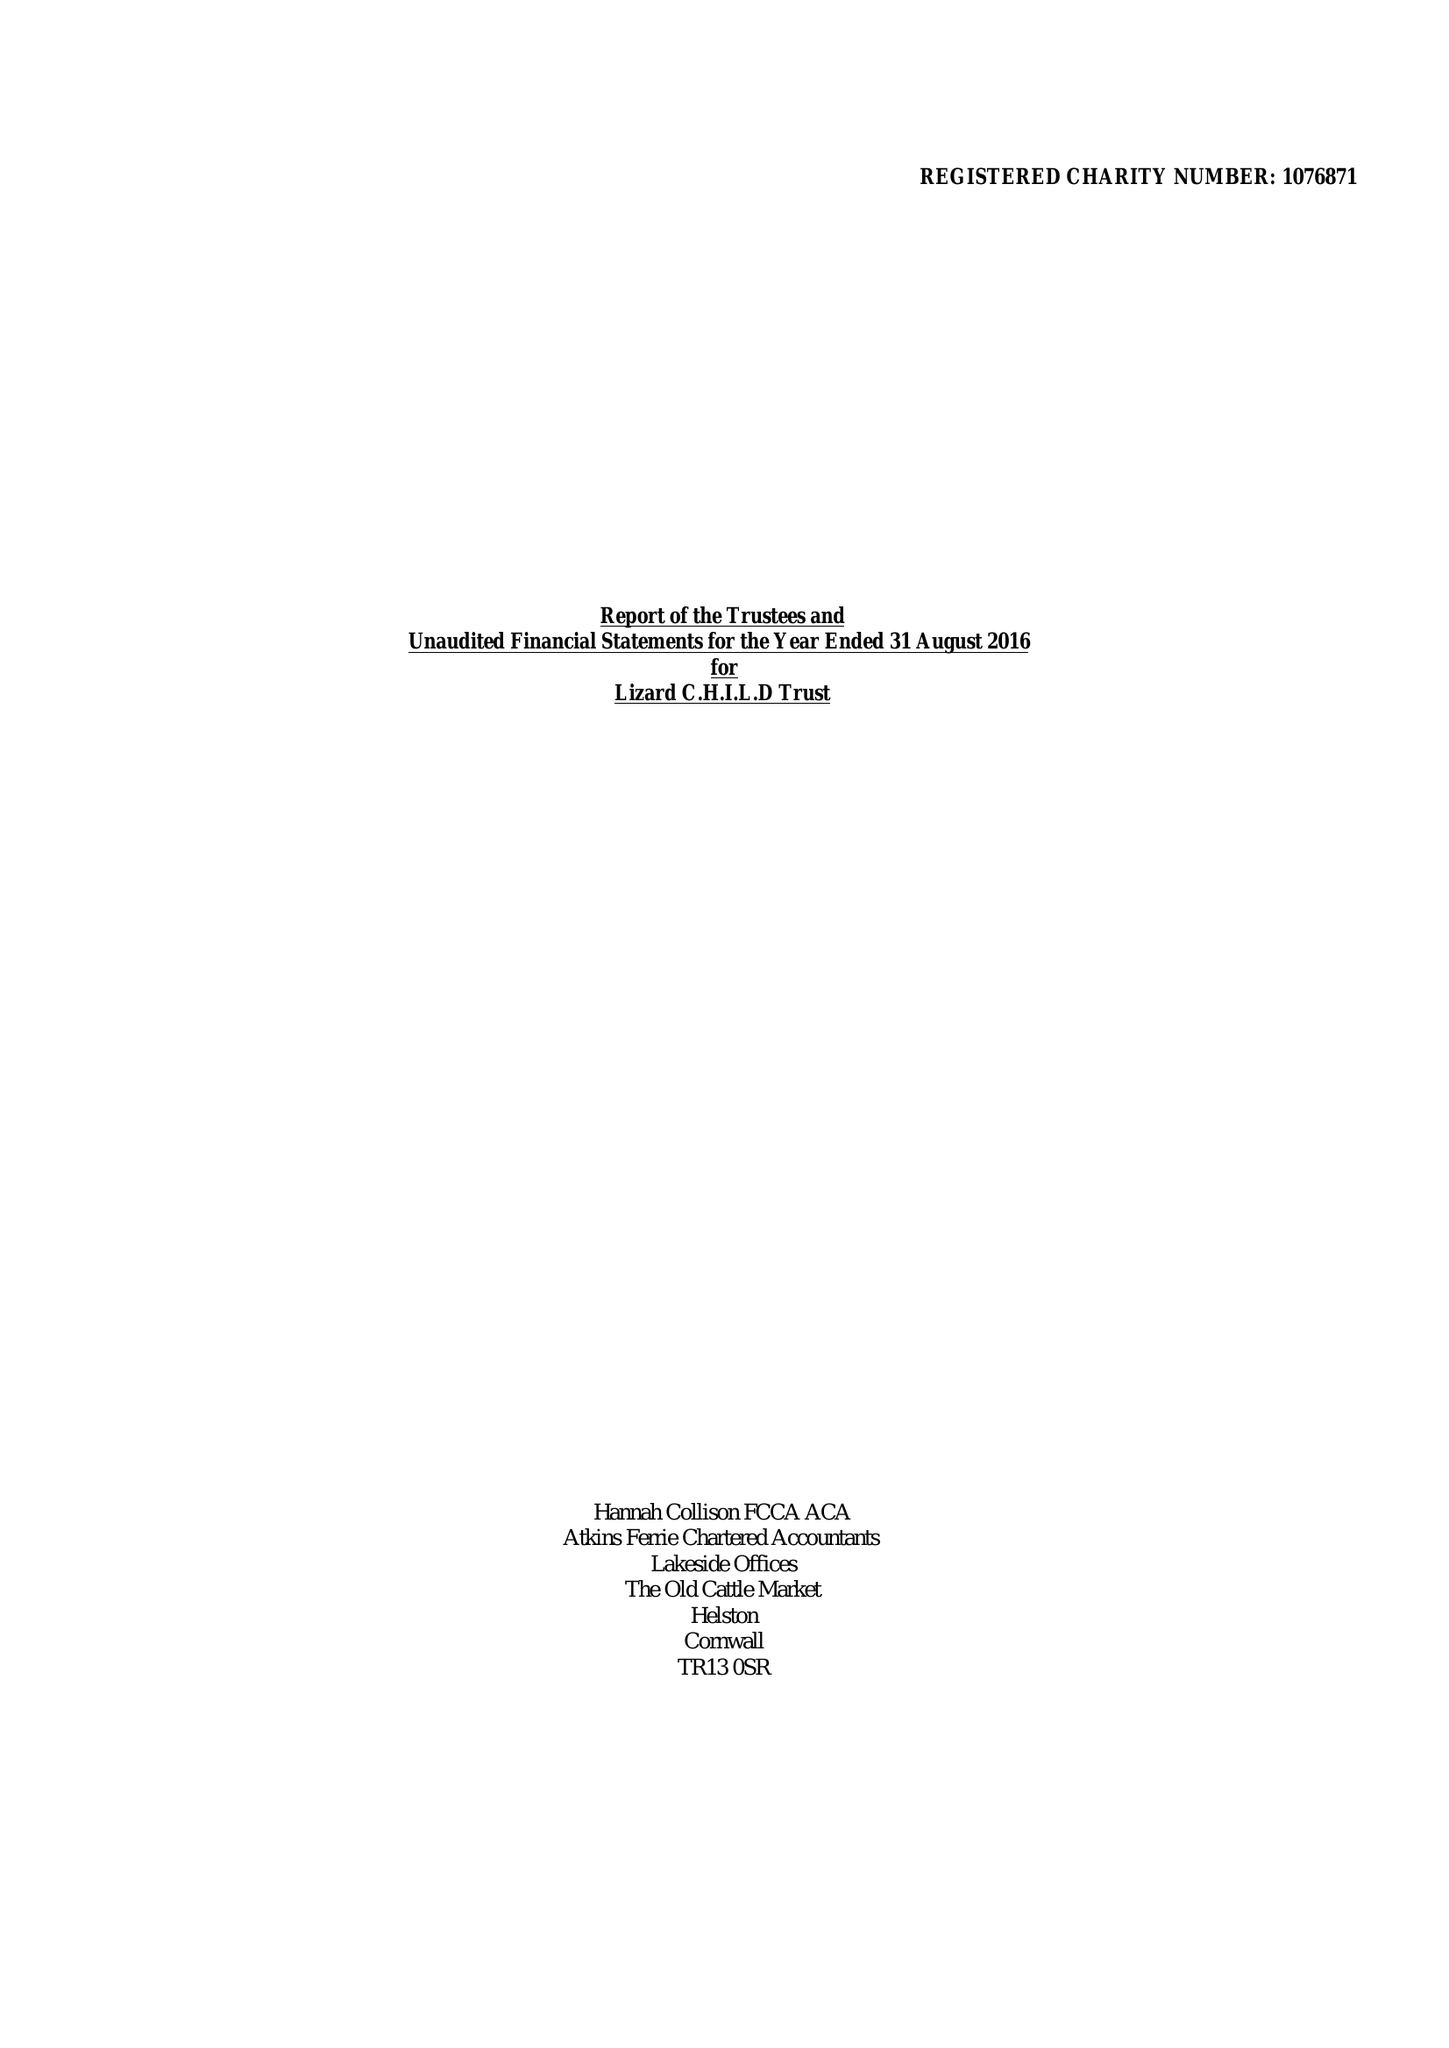What is the value for the address__postcode?
Answer the question using a single word or phrase. TR13 8AR 